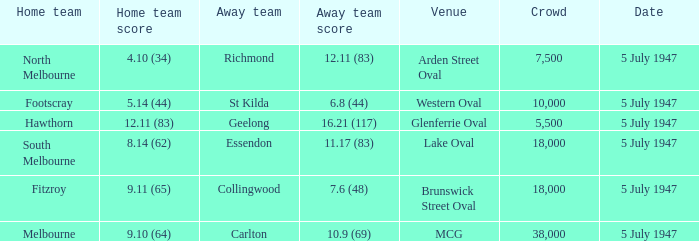What did the home team score when the away team scored 12.11 (83)? 4.10 (34). Parse the full table. {'header': ['Home team', 'Home team score', 'Away team', 'Away team score', 'Venue', 'Crowd', 'Date'], 'rows': [['North Melbourne', '4.10 (34)', 'Richmond', '12.11 (83)', 'Arden Street Oval', '7,500', '5 July 1947'], ['Footscray', '5.14 (44)', 'St Kilda', '6.8 (44)', 'Western Oval', '10,000', '5 July 1947'], ['Hawthorn', '12.11 (83)', 'Geelong', '16.21 (117)', 'Glenferrie Oval', '5,500', '5 July 1947'], ['South Melbourne', '8.14 (62)', 'Essendon', '11.17 (83)', 'Lake Oval', '18,000', '5 July 1947'], ['Fitzroy', '9.11 (65)', 'Collingwood', '7.6 (48)', 'Brunswick Street Oval', '18,000', '5 July 1947'], ['Melbourne', '9.10 (64)', 'Carlton', '10.9 (69)', 'MCG', '38,000', '5 July 1947']]} 